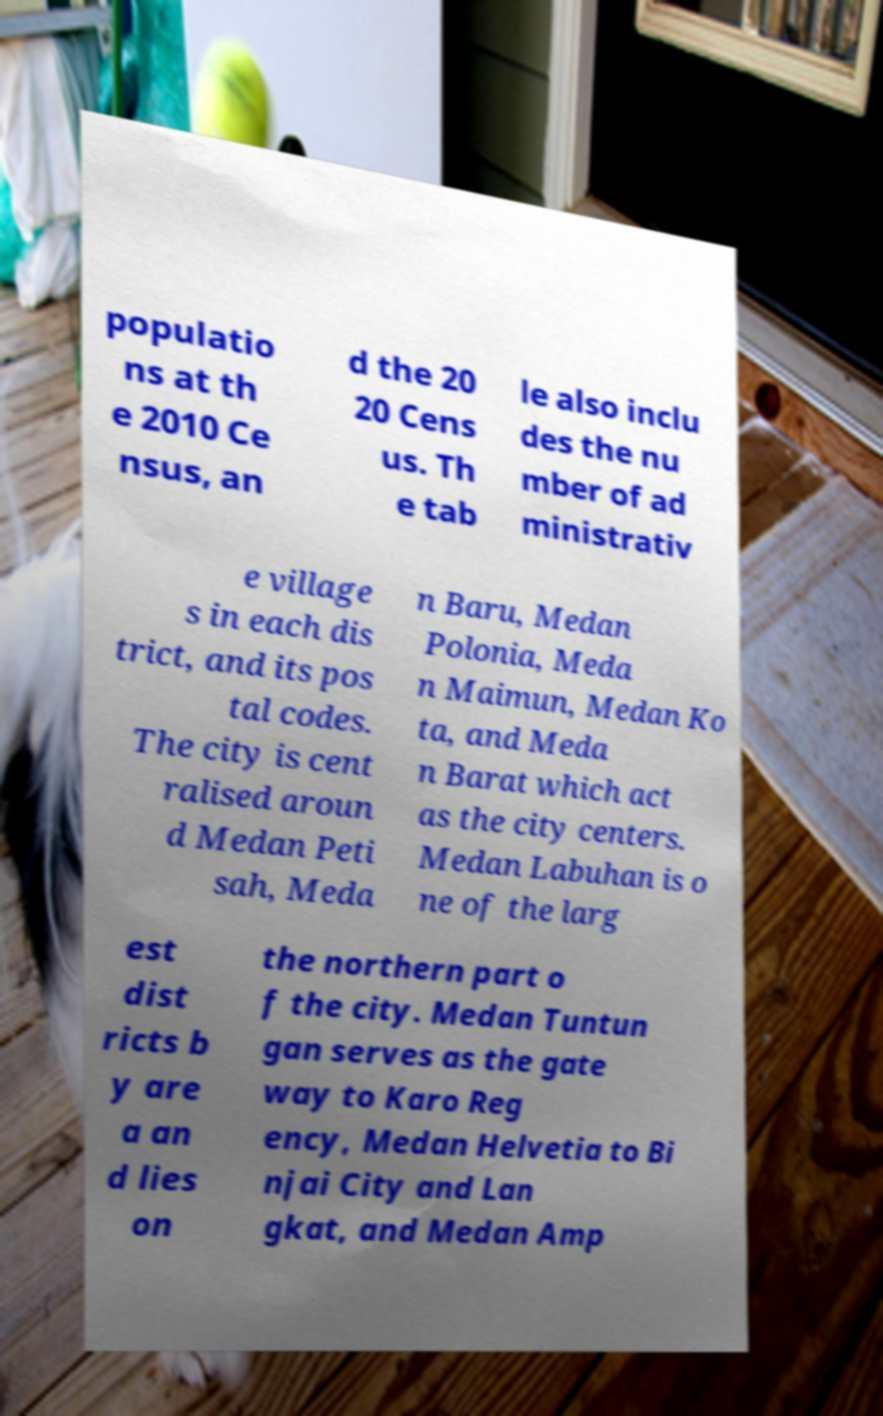Could you assist in decoding the text presented in this image and type it out clearly? populatio ns at th e 2010 Ce nsus, an d the 20 20 Cens us. Th e tab le also inclu des the nu mber of ad ministrativ e village s in each dis trict, and its pos tal codes. The city is cent ralised aroun d Medan Peti sah, Meda n Baru, Medan Polonia, Meda n Maimun, Medan Ko ta, and Meda n Barat which act as the city centers. Medan Labuhan is o ne of the larg est dist ricts b y are a an d lies on the northern part o f the city. Medan Tuntun gan serves as the gate way to Karo Reg ency, Medan Helvetia to Bi njai City and Lan gkat, and Medan Amp 